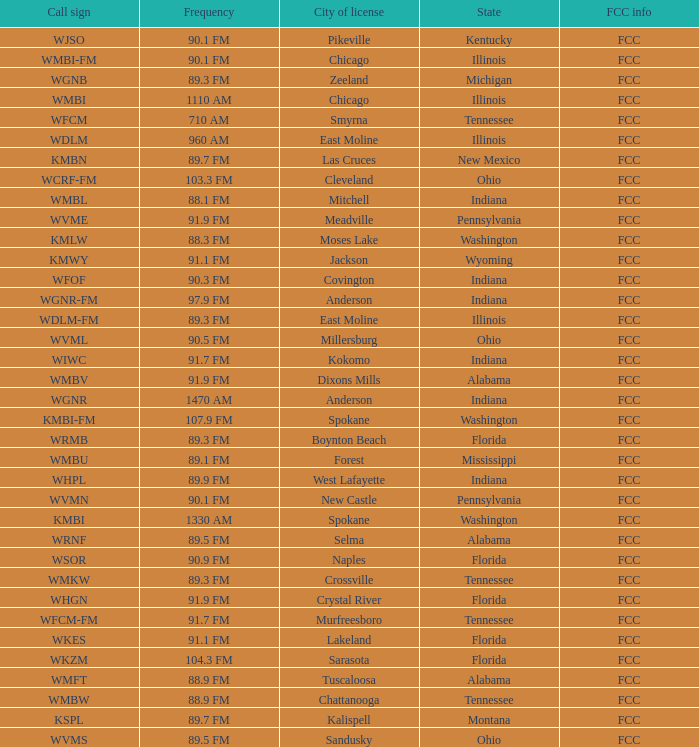What is the call sign for 90.9 FM which is in Florida? WSOR. 